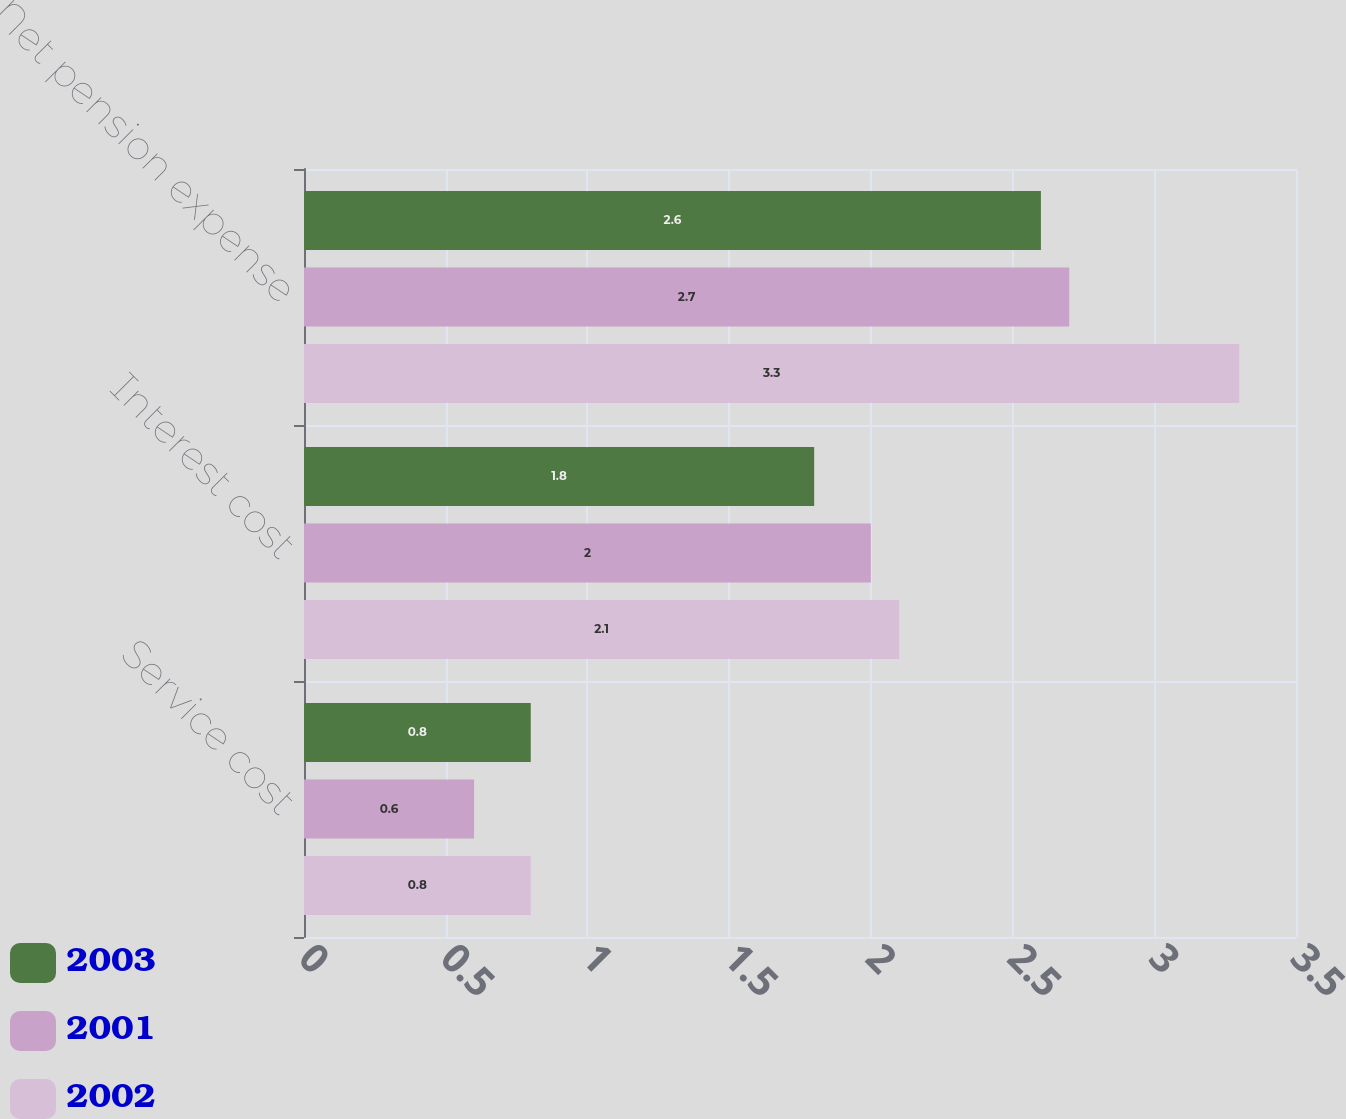<chart> <loc_0><loc_0><loc_500><loc_500><stacked_bar_chart><ecel><fcel>Service cost<fcel>Interest cost<fcel>Net pension expense<nl><fcel>2003<fcel>0.8<fcel>1.8<fcel>2.6<nl><fcel>2001<fcel>0.6<fcel>2<fcel>2.7<nl><fcel>2002<fcel>0.8<fcel>2.1<fcel>3.3<nl></chart> 